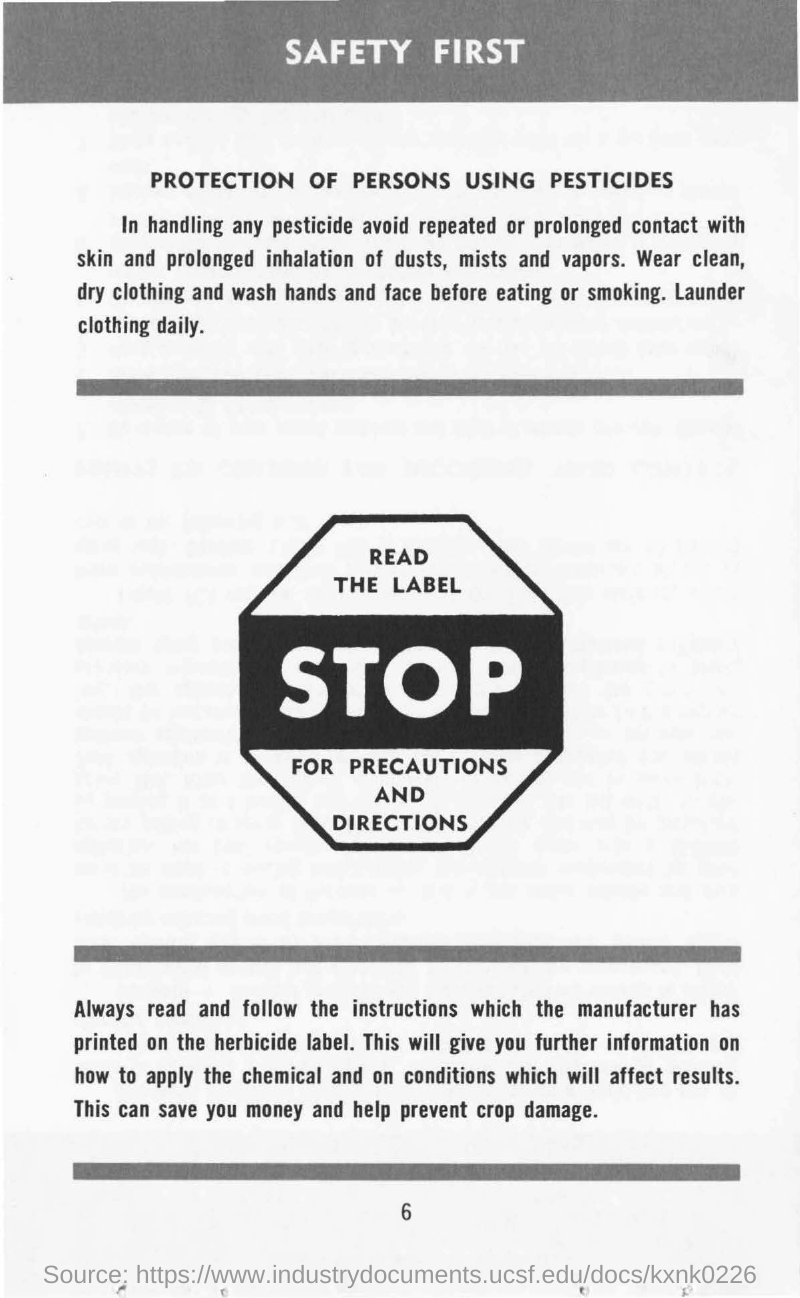What we have to read and follow?
Give a very brief answer. INSTRUCTIONS. What is first?
Your answer should be very brief. SAFETY FIRST. Where the instructions are printed?
Your response must be concise. Herbicide label. By whom the instructions are printed?
Provide a succinct answer. Manufacturer. 